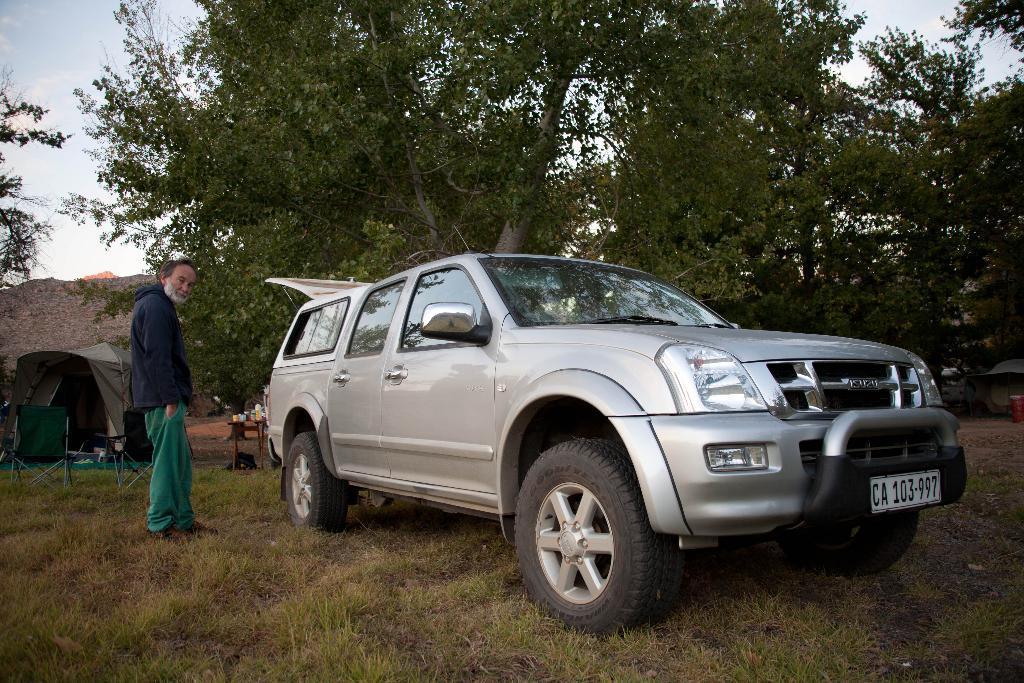Can you describe this image briefly? In this image we can see a car on the ground and a person standing near the car, there is a tent, chair, table with some objects on the table, few trees, mountains and the sky in the background. 